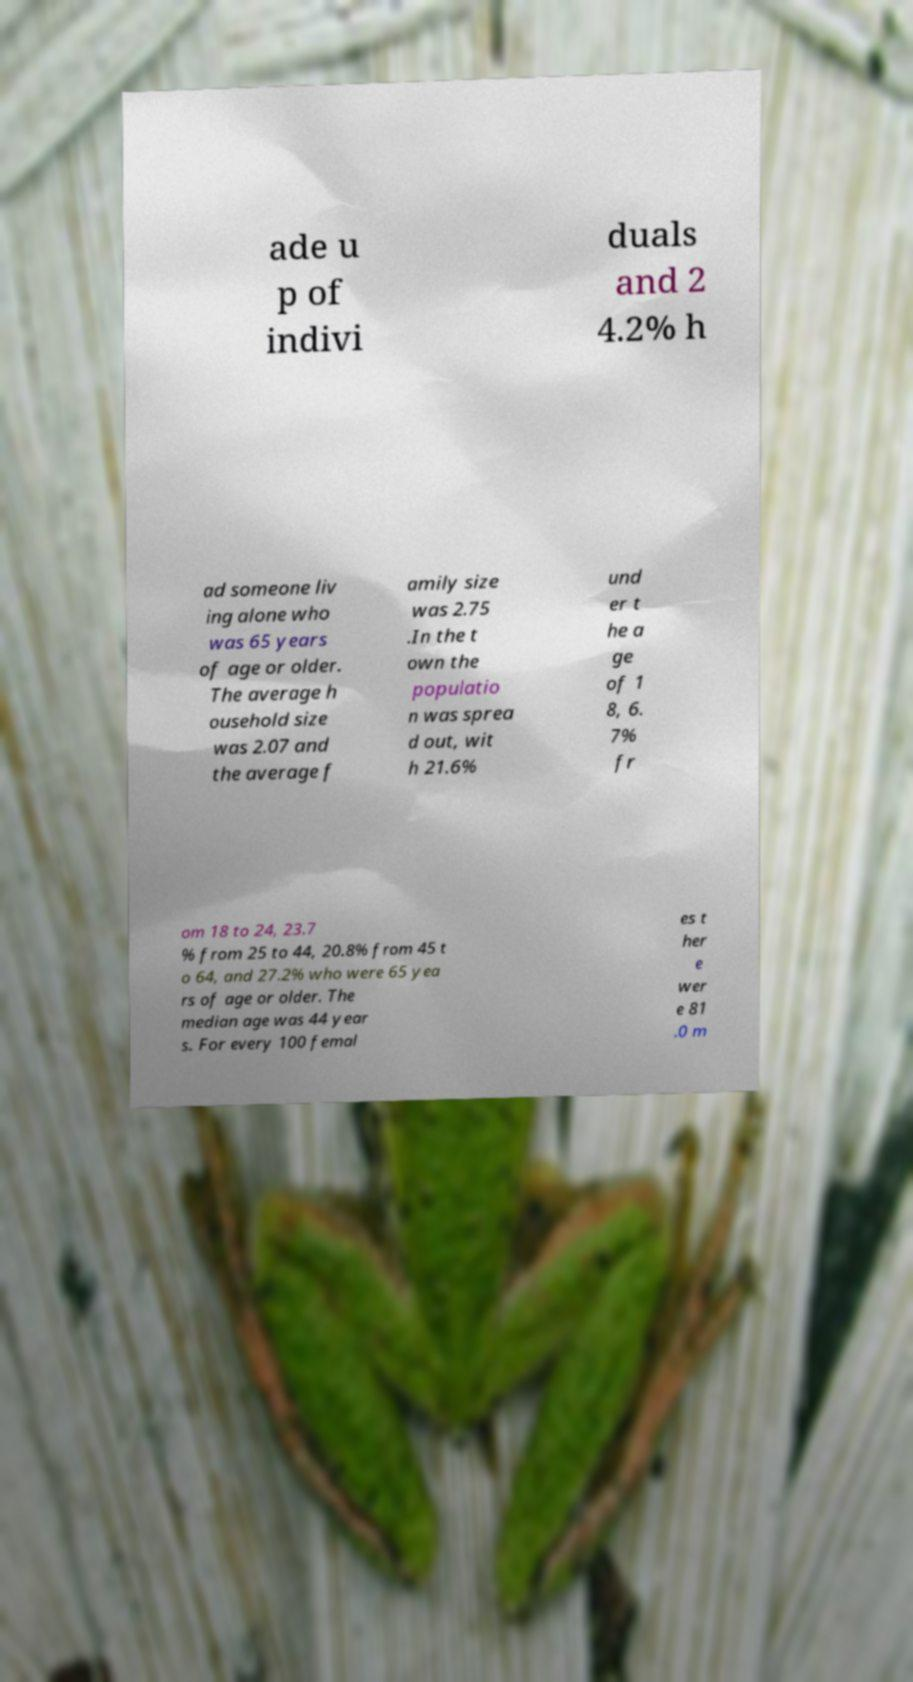Please read and relay the text visible in this image. What does it say? ade u p of indivi duals and 2 4.2% h ad someone liv ing alone who was 65 years of age or older. The average h ousehold size was 2.07 and the average f amily size was 2.75 .In the t own the populatio n was sprea d out, wit h 21.6% und er t he a ge of 1 8, 6. 7% fr om 18 to 24, 23.7 % from 25 to 44, 20.8% from 45 t o 64, and 27.2% who were 65 yea rs of age or older. The median age was 44 year s. For every 100 femal es t her e wer e 81 .0 m 